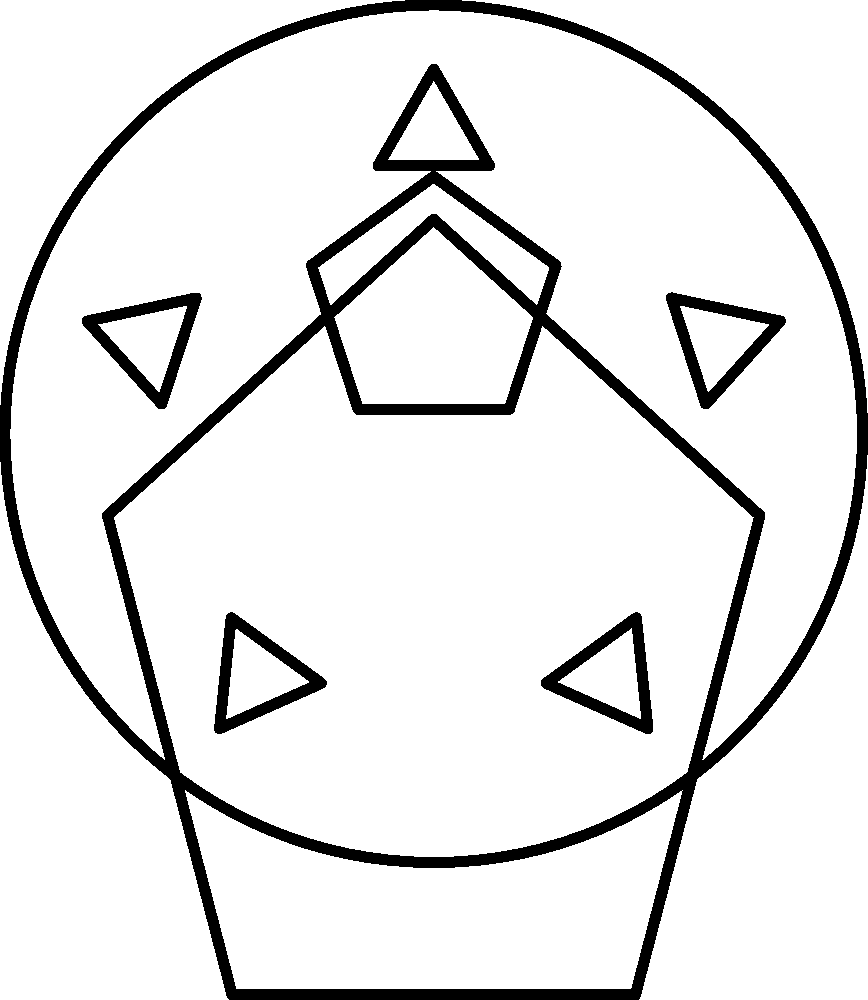Analyze the rotational symmetry of the given team logo. What is the order of rotational symmetry for the entire logo, and how does it relate to the individual elements within the design? Let's analyze the rotational symmetry of the logo step-by-step:

1. The logo consists of several elements:
   a) A circular outer border
   b) A shield-like shape in the center
   c) A star in the upper part of the shield
   d) Five triangular shapes around the top of the circle

2. Rotational symmetry of individual elements:
   a) The circular border has infinite rotational symmetry (order $\infty$)
   b) The shield-like shape has 2-fold rotational symmetry (order 2)
   c) The star has 5-fold rotational symmetry (order 5)
   d) The arrangement of triangles has 5-fold rotational symmetry (order 5)

3. To determine the overall rotational symmetry, we need to find the highest common factor of the orders of symmetry for all elements:
   $HCF(\infty, 2, 5, 5) = 1$

4. The star and the arrangement of triangles both have 5-fold symmetry, which is the highest finite order of symmetry in the logo.

5. However, the shield-like shape breaks this 5-fold symmetry, as it only has 2-fold symmetry.

6. The circular border doesn't affect the overall rotational symmetry, as it's symmetrical for any rotation.

Therefore, the entire logo has only 1-fold rotational symmetry (order 1), meaning it has no rotational symmetry other than a full 360° rotation. The 5-fold symmetry of some elements is broken by the 2-fold symmetry of the shield, resulting in no overall rotational symmetry for the complete logo.
Answer: Order 1 (no rotational symmetry) 